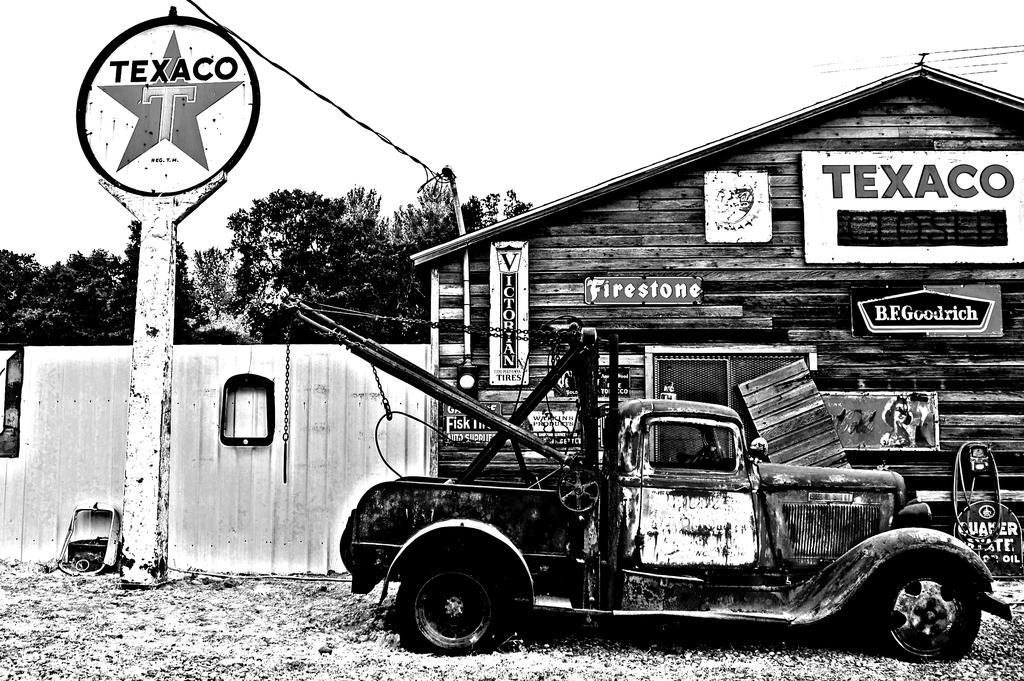Can you describe this image briefly? In the picture I can see a vehicle and there is a wooden house which has something written on it and there is a pole in the left corner and there are trees in the background. 